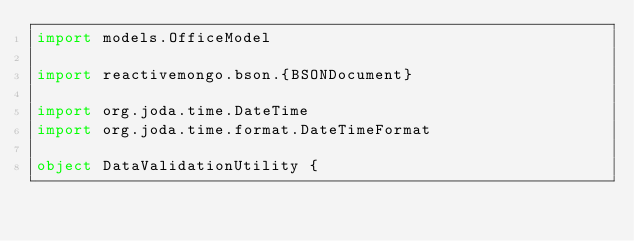<code> <loc_0><loc_0><loc_500><loc_500><_Scala_>import models.OfficeModel

import reactivemongo.bson.{BSONDocument}

import org.joda.time.DateTime
import org.joda.time.format.DateTimeFormat

object DataValidationUtility {</code> 